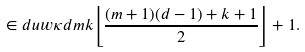<formula> <loc_0><loc_0><loc_500><loc_500>\in d u w { \kappa } d m k { \left \lfloor { \frac { ( m + 1 ) ( d - 1 ) + k + 1 } { 2 } } \right \rfloor + 1 } .</formula> 